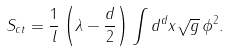<formula> <loc_0><loc_0><loc_500><loc_500>S _ { c t } = \frac { 1 } { l } \left ( \lambda - \frac { d } 2 \right ) \int d ^ { d } x \sqrt { g } \, \phi ^ { 2 } .</formula> 